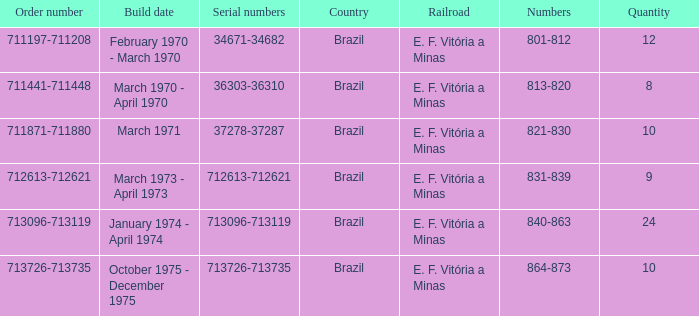The order number 713726-713735 has what serial number? 713726-713735. 